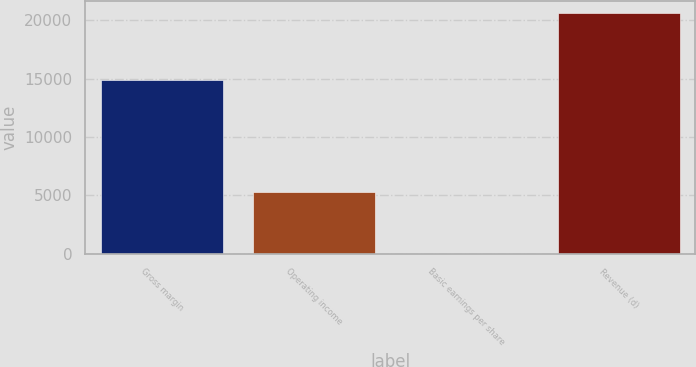<chart> <loc_0><loc_0><loc_500><loc_500><bar_chart><fcel>Gross margin<fcel>Operating income<fcel>Basic earnings per share<fcel>Revenue (d)<nl><fcel>14861<fcel>5330<fcel>0.84<fcel>20614<nl></chart> 